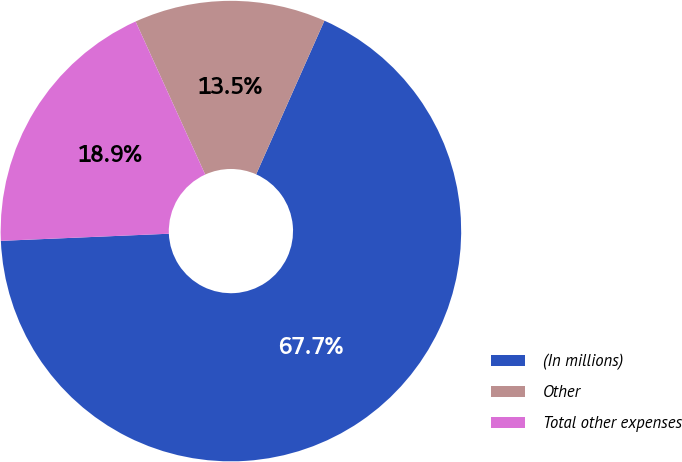Convert chart. <chart><loc_0><loc_0><loc_500><loc_500><pie_chart><fcel>(In millions)<fcel>Other<fcel>Total other expenses<nl><fcel>67.67%<fcel>13.45%<fcel>18.88%<nl></chart> 